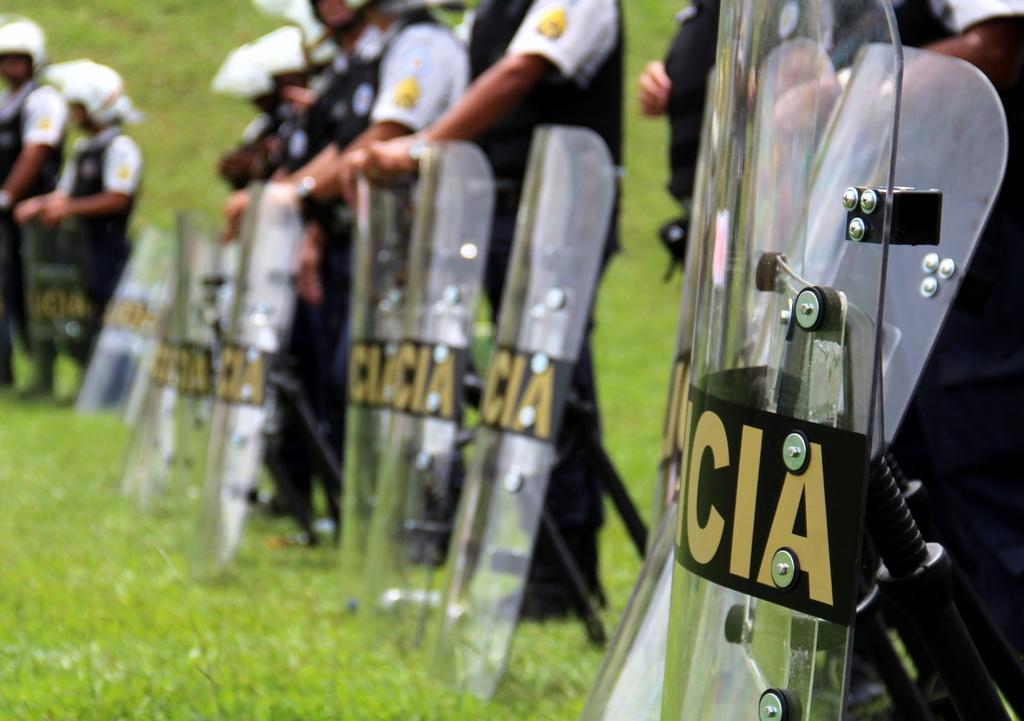Can you describe this image briefly? The picture consists of soldiers holding shields. In this picture there is grass also. 